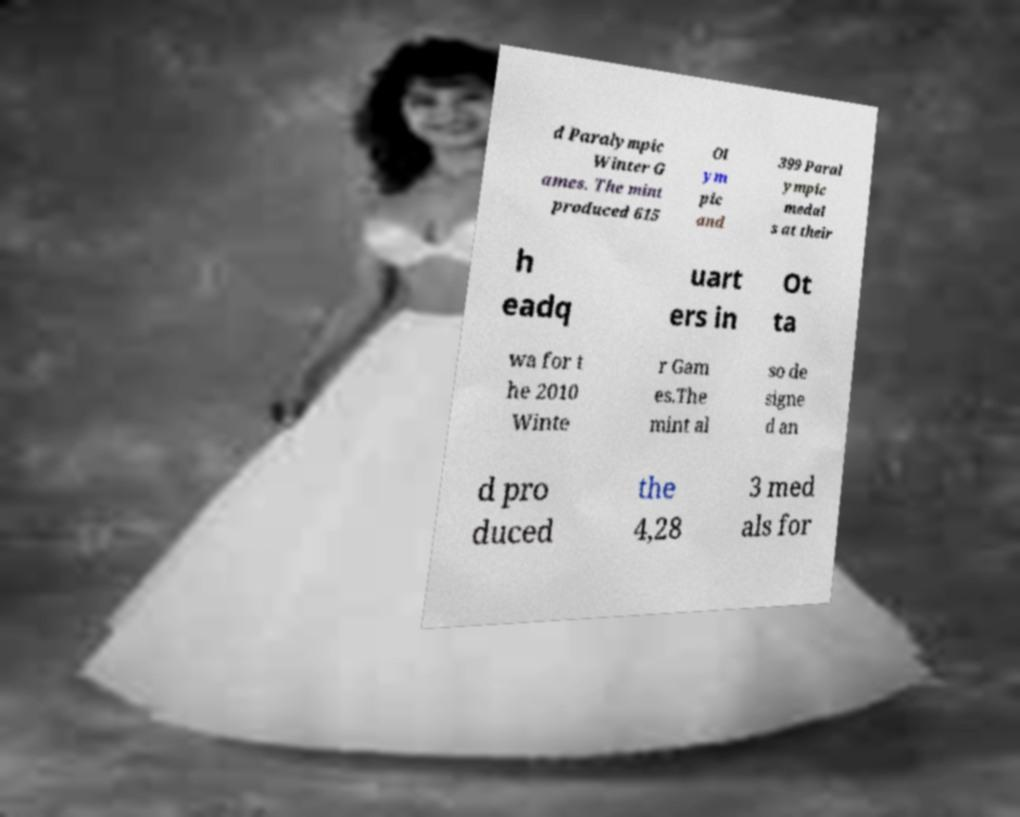Can you read and provide the text displayed in the image?This photo seems to have some interesting text. Can you extract and type it out for me? d Paralympic Winter G ames. The mint produced 615 Ol ym pic and 399 Paral ympic medal s at their h eadq uart ers in Ot ta wa for t he 2010 Winte r Gam es.The mint al so de signe d an d pro duced the 4,28 3 med als for 